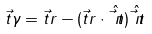Convert formula to latex. <formula><loc_0><loc_0><loc_500><loc_500>\vec { t } { \gamma } = \vec { t } { r } - ( \vec { t } { r } \cdot \hat { \vec { t } { n } } ) \hat { \vec { t } { n } }</formula> 